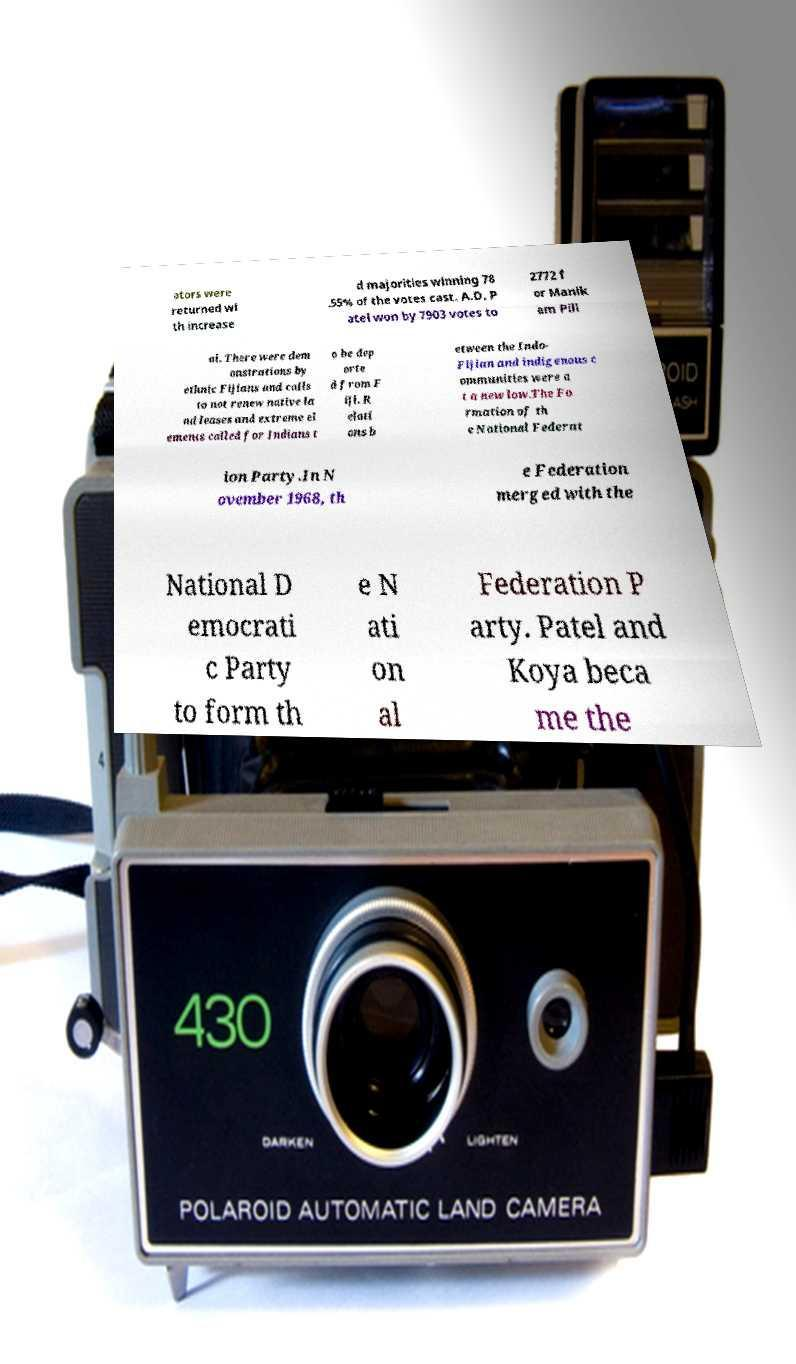For documentation purposes, I need the text within this image transcribed. Could you provide that? ators were returned wi th increase d majorities winning 78 .55% of the votes cast. A.D. P atel won by 7903 votes to 2772 f or Manik am Pill ai. There were dem onstrations by ethnic Fijians and calls to not renew native la nd leases and extreme el ements called for Indians t o be dep orte d from F iji. R elati ons b etween the Indo- Fijian and indigenous c ommunities were a t a new low.The Fo rmation of th e National Federat ion Party.In N ovember 1968, th e Federation merged with the National D emocrati c Party to form th e N ati on al Federation P arty. Patel and Koya beca me the 